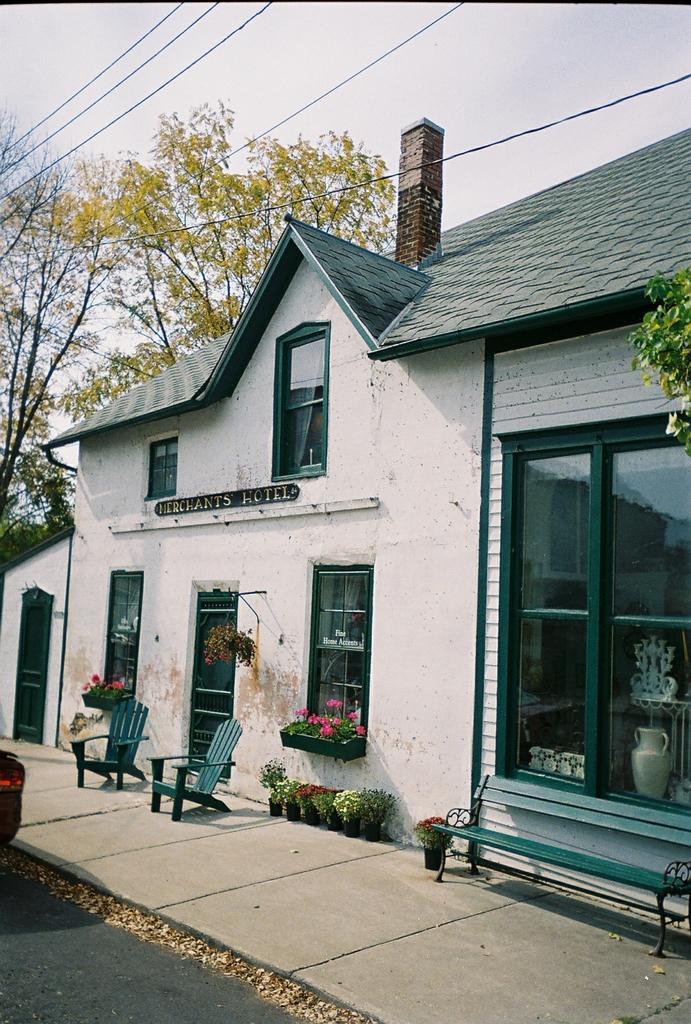Can you describe this image briefly? In this image in the middle there is a house, windows, door, chairs, glass, bench, house plant, trees, roof, chimney, road and sky. 